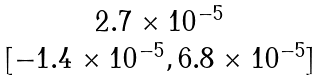Convert formula to latex. <formula><loc_0><loc_0><loc_500><loc_500>\begin{matrix} 2 . 7 \times 1 0 ^ { - 5 } \\ [ - 1 . 4 \times 1 0 ^ { - 5 } , 6 . 8 \times 1 0 ^ { - 5 } ] \end{matrix}</formula> 